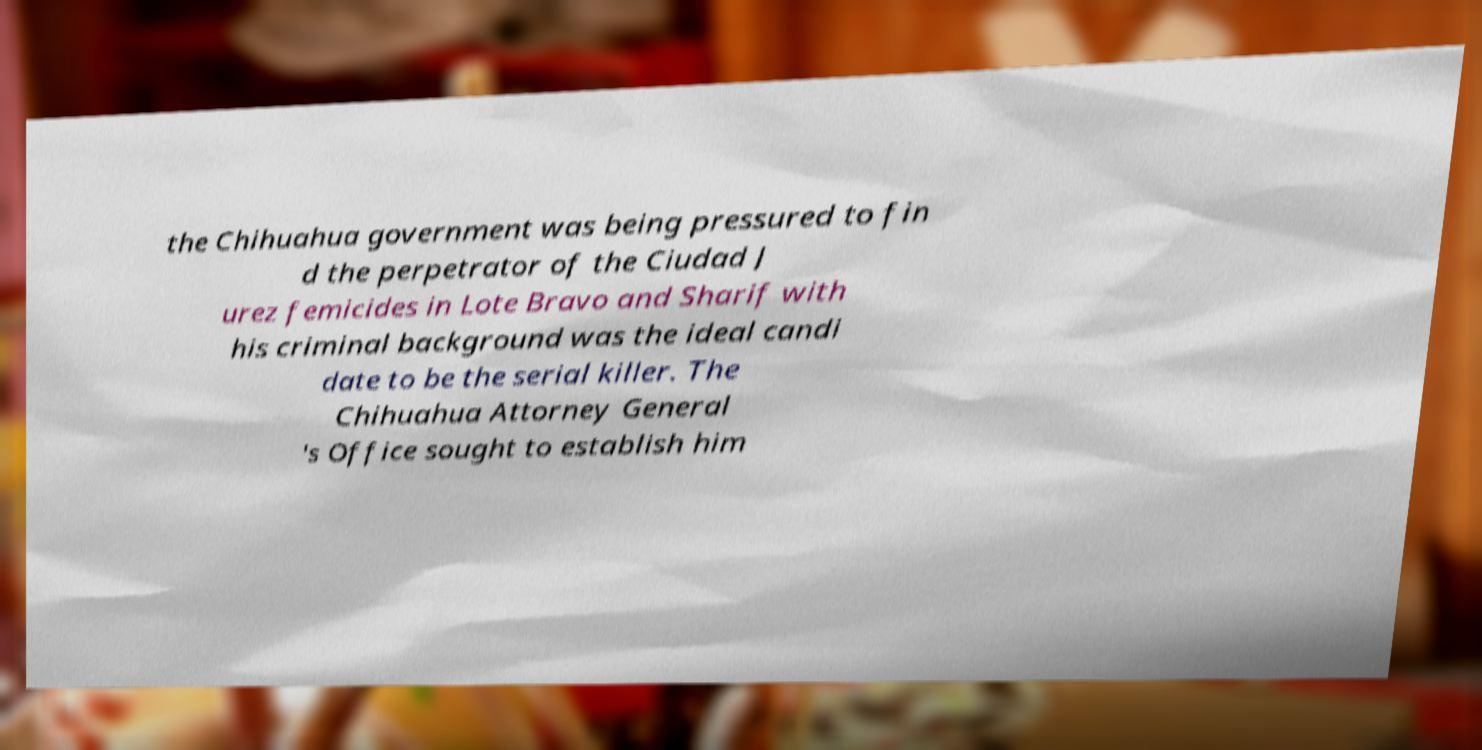Can you read and provide the text displayed in the image?This photo seems to have some interesting text. Can you extract and type it out for me? the Chihuahua government was being pressured to fin d the perpetrator of the Ciudad J urez femicides in Lote Bravo and Sharif with his criminal background was the ideal candi date to be the serial killer. The Chihuahua Attorney General 's Office sought to establish him 